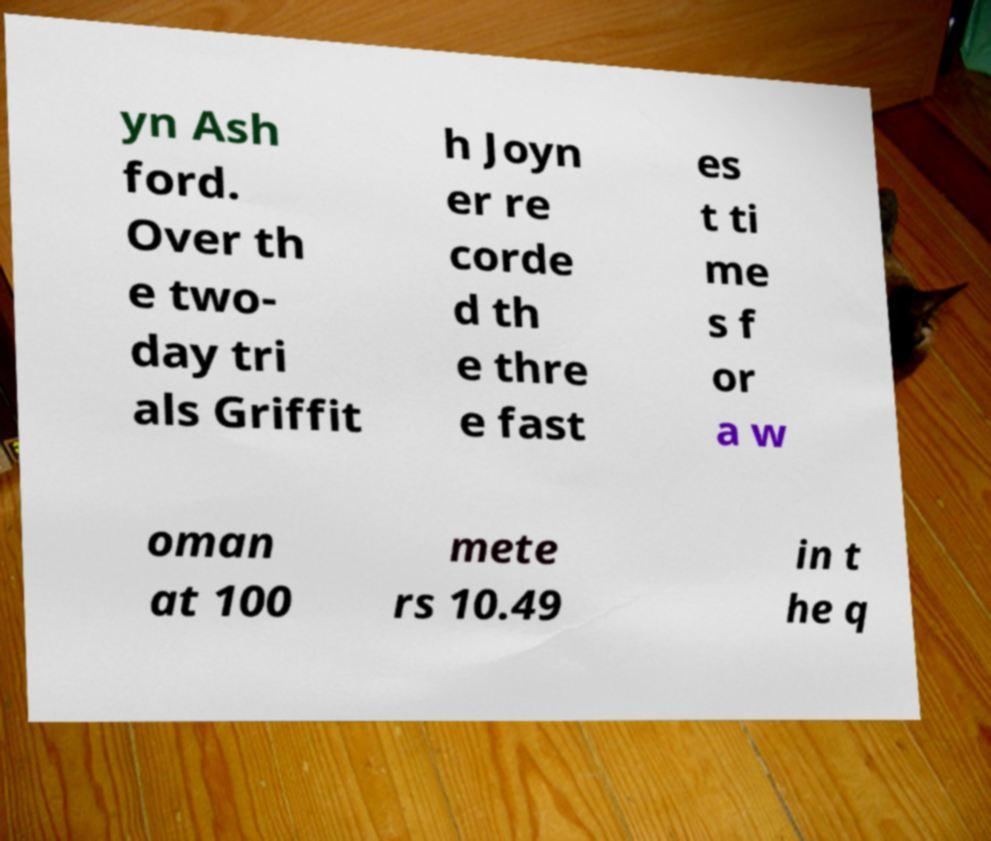Could you assist in decoding the text presented in this image and type it out clearly? yn Ash ford. Over th e two- day tri als Griffit h Joyn er re corde d th e thre e fast es t ti me s f or a w oman at 100 mete rs 10.49 in t he q 